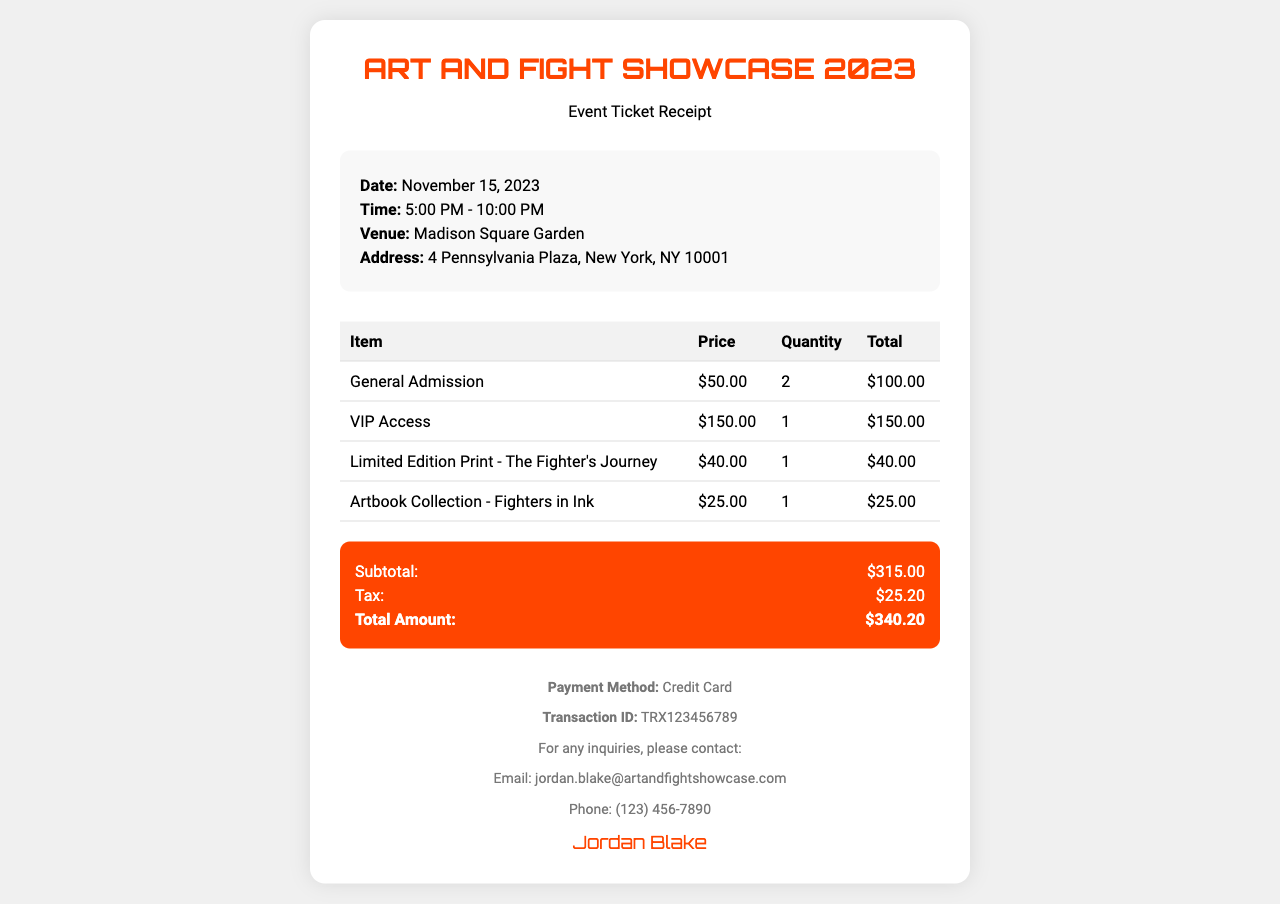What is the date of the event? The date is explicitly stated in the document as November 15, 2023.
Answer: November 15, 2023 What is the price of VIP access? The document lists the price for VIP access clearly as $150.00.
Answer: $150.00 How many general admission tickets were purchased? The quantity of general admission tickets purchased is specified in the item row as 2.
Answer: 2 What is the total amount after tax? The total amount at the end of the receipt sums the subtotal and tax, calculated as $315.00 + $25.20.
Answer: $340.20 What is the email address for inquiries? The email address for inquiries is provided in the footer section as jordan.blake@artandfightshowcase.com.
Answer: jordan.blake@artandfightshowcase.com What merchandise was bought with the ticket? The merchandise purchased includes a limited edition print and an artbook collection, listed in the table of items.
Answer: Limited Edition Print, Artbook Collection What method of payment was used? The payment method is stated in the footer as Credit Card.
Answer: Credit Card How much tax was applied? The tax amount is detailed in the summary section as $25.20.
Answer: $25.20 